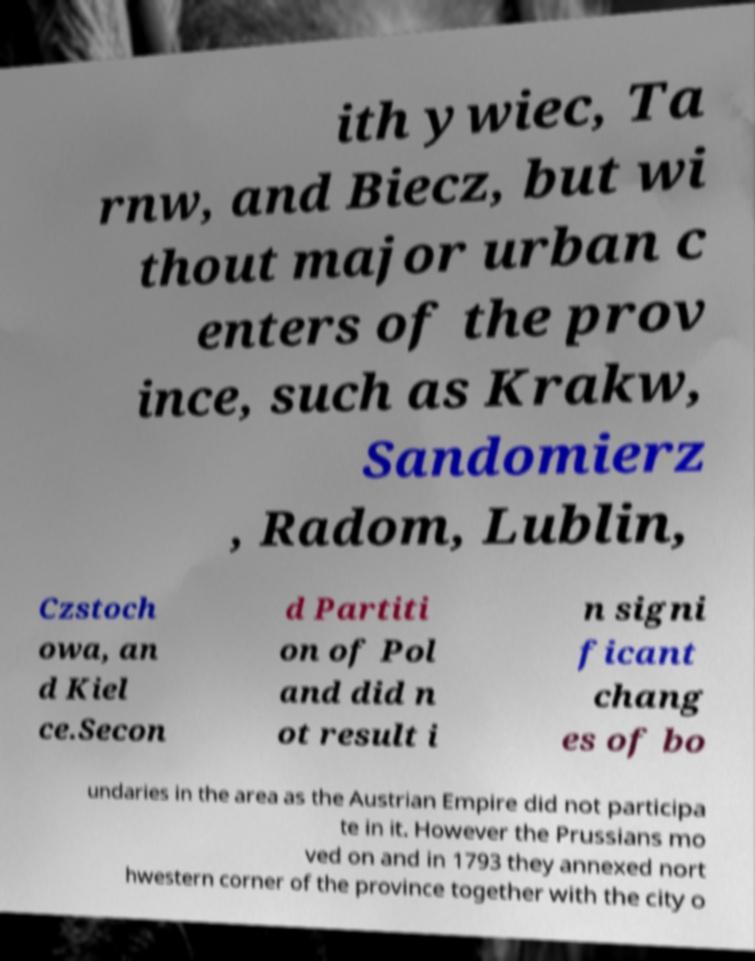Could you assist in decoding the text presented in this image and type it out clearly? ith ywiec, Ta rnw, and Biecz, but wi thout major urban c enters of the prov ince, such as Krakw, Sandomierz , Radom, Lublin, Czstoch owa, an d Kiel ce.Secon d Partiti on of Pol and did n ot result i n signi ficant chang es of bo undaries in the area as the Austrian Empire did not participa te in it. However the Prussians mo ved on and in 1793 they annexed nort hwestern corner of the province together with the city o 